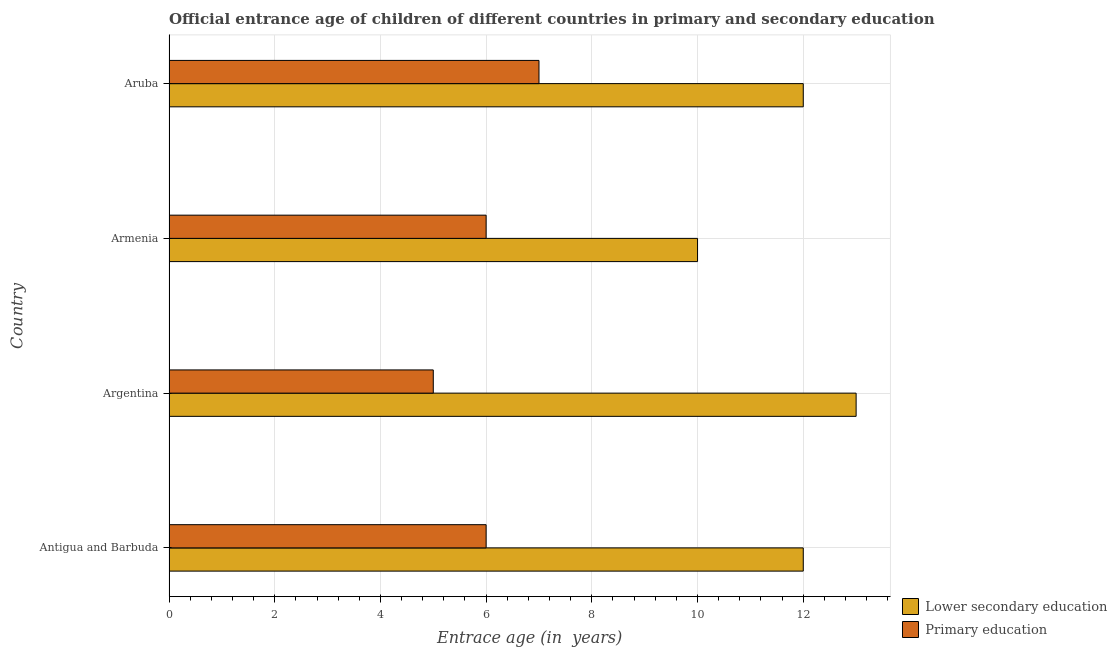How many different coloured bars are there?
Offer a very short reply. 2. How many groups of bars are there?
Give a very brief answer. 4. Are the number of bars per tick equal to the number of legend labels?
Keep it short and to the point. Yes. Are the number of bars on each tick of the Y-axis equal?
Your answer should be compact. Yes. What is the label of the 1st group of bars from the top?
Provide a succinct answer. Aruba. In how many cases, is the number of bars for a given country not equal to the number of legend labels?
Provide a short and direct response. 0. What is the entrance age of children in lower secondary education in Antigua and Barbuda?
Provide a short and direct response. 12. Across all countries, what is the maximum entrance age of children in lower secondary education?
Your answer should be very brief. 13. Across all countries, what is the minimum entrance age of children in lower secondary education?
Your response must be concise. 10. In which country was the entrance age of chiildren in primary education maximum?
Give a very brief answer. Aruba. In which country was the entrance age of chiildren in primary education minimum?
Your response must be concise. Argentina. What is the total entrance age of chiildren in primary education in the graph?
Your answer should be very brief. 24. What is the difference between the entrance age of children in lower secondary education in Antigua and Barbuda and that in Aruba?
Provide a short and direct response. 0. What is the difference between the entrance age of chiildren in primary education in Argentina and the entrance age of children in lower secondary education in Armenia?
Offer a very short reply. -5. What is the average entrance age of children in lower secondary education per country?
Provide a succinct answer. 11.75. In how many countries, is the entrance age of children in lower secondary education greater than 12.8 years?
Make the answer very short. 1. What is the ratio of the entrance age of chiildren in primary education in Antigua and Barbuda to that in Aruba?
Make the answer very short. 0.86. Is the entrance age of chiildren in primary education in Argentina less than that in Aruba?
Provide a succinct answer. Yes. Is the difference between the entrance age of children in lower secondary education in Argentina and Armenia greater than the difference between the entrance age of chiildren in primary education in Argentina and Armenia?
Offer a terse response. Yes. What is the difference between the highest and the lowest entrance age of children in lower secondary education?
Ensure brevity in your answer.  3. In how many countries, is the entrance age of chiildren in primary education greater than the average entrance age of chiildren in primary education taken over all countries?
Keep it short and to the point. 1. Is the sum of the entrance age of chiildren in primary education in Argentina and Armenia greater than the maximum entrance age of children in lower secondary education across all countries?
Keep it short and to the point. No. What does the 2nd bar from the top in Antigua and Barbuda represents?
Make the answer very short. Lower secondary education. How many bars are there?
Keep it short and to the point. 8. Are all the bars in the graph horizontal?
Ensure brevity in your answer.  Yes. Does the graph contain any zero values?
Make the answer very short. No. Where does the legend appear in the graph?
Offer a very short reply. Bottom right. What is the title of the graph?
Your answer should be very brief. Official entrance age of children of different countries in primary and secondary education. What is the label or title of the X-axis?
Offer a very short reply. Entrace age (in  years). What is the label or title of the Y-axis?
Keep it short and to the point. Country. What is the Entrace age (in  years) of Lower secondary education in Antigua and Barbuda?
Offer a terse response. 12. What is the Entrace age (in  years) in Primary education in Antigua and Barbuda?
Ensure brevity in your answer.  6. What is the Entrace age (in  years) of Lower secondary education in Argentina?
Your answer should be compact. 13. What is the Entrace age (in  years) in Lower secondary education in Armenia?
Your answer should be very brief. 10. What is the Entrace age (in  years) of Lower secondary education in Aruba?
Offer a terse response. 12. What is the total Entrace age (in  years) of Primary education in the graph?
Offer a terse response. 24. What is the difference between the Entrace age (in  years) of Lower secondary education in Antigua and Barbuda and that in Argentina?
Your answer should be very brief. -1. What is the difference between the Entrace age (in  years) in Primary education in Antigua and Barbuda and that in Argentina?
Ensure brevity in your answer.  1. What is the difference between the Entrace age (in  years) in Lower secondary education in Antigua and Barbuda and that in Armenia?
Your answer should be compact. 2. What is the difference between the Entrace age (in  years) in Primary education in Antigua and Barbuda and that in Aruba?
Your response must be concise. -1. What is the difference between the Entrace age (in  years) of Primary education in Argentina and that in Armenia?
Your answer should be very brief. -1. What is the difference between the Entrace age (in  years) of Primary education in Argentina and that in Aruba?
Ensure brevity in your answer.  -2. What is the difference between the Entrace age (in  years) of Lower secondary education in Armenia and that in Aruba?
Provide a short and direct response. -2. What is the difference between the Entrace age (in  years) in Lower secondary education in Antigua and Barbuda and the Entrace age (in  years) in Primary education in Argentina?
Give a very brief answer. 7. What is the difference between the Entrace age (in  years) in Lower secondary education in Antigua and Barbuda and the Entrace age (in  years) in Primary education in Armenia?
Provide a short and direct response. 6. What is the difference between the Entrace age (in  years) of Lower secondary education in Argentina and the Entrace age (in  years) of Primary education in Armenia?
Your answer should be very brief. 7. What is the difference between the Entrace age (in  years) in Lower secondary education in Armenia and the Entrace age (in  years) in Primary education in Aruba?
Your response must be concise. 3. What is the average Entrace age (in  years) of Lower secondary education per country?
Keep it short and to the point. 11.75. What is the difference between the Entrace age (in  years) in Lower secondary education and Entrace age (in  years) in Primary education in Argentina?
Ensure brevity in your answer.  8. What is the difference between the Entrace age (in  years) of Lower secondary education and Entrace age (in  years) of Primary education in Armenia?
Keep it short and to the point. 4. What is the difference between the Entrace age (in  years) in Lower secondary education and Entrace age (in  years) in Primary education in Aruba?
Make the answer very short. 5. What is the ratio of the Entrace age (in  years) in Lower secondary education in Antigua and Barbuda to that in Armenia?
Make the answer very short. 1.2. What is the ratio of the Entrace age (in  years) of Primary education in Antigua and Barbuda to that in Armenia?
Your answer should be very brief. 1. What is the ratio of the Entrace age (in  years) of Lower secondary education in Antigua and Barbuda to that in Aruba?
Ensure brevity in your answer.  1. What is the ratio of the Entrace age (in  years) of Primary education in Argentina to that in Armenia?
Your response must be concise. 0.83. What is the ratio of the Entrace age (in  years) in Lower secondary education in Argentina to that in Aruba?
Keep it short and to the point. 1.08. What is the ratio of the Entrace age (in  years) of Primary education in Armenia to that in Aruba?
Make the answer very short. 0.86. What is the difference between the highest and the second highest Entrace age (in  years) in Lower secondary education?
Keep it short and to the point. 1. What is the difference between the highest and the second highest Entrace age (in  years) of Primary education?
Your answer should be compact. 1. What is the difference between the highest and the lowest Entrace age (in  years) of Lower secondary education?
Ensure brevity in your answer.  3. What is the difference between the highest and the lowest Entrace age (in  years) in Primary education?
Provide a succinct answer. 2. 